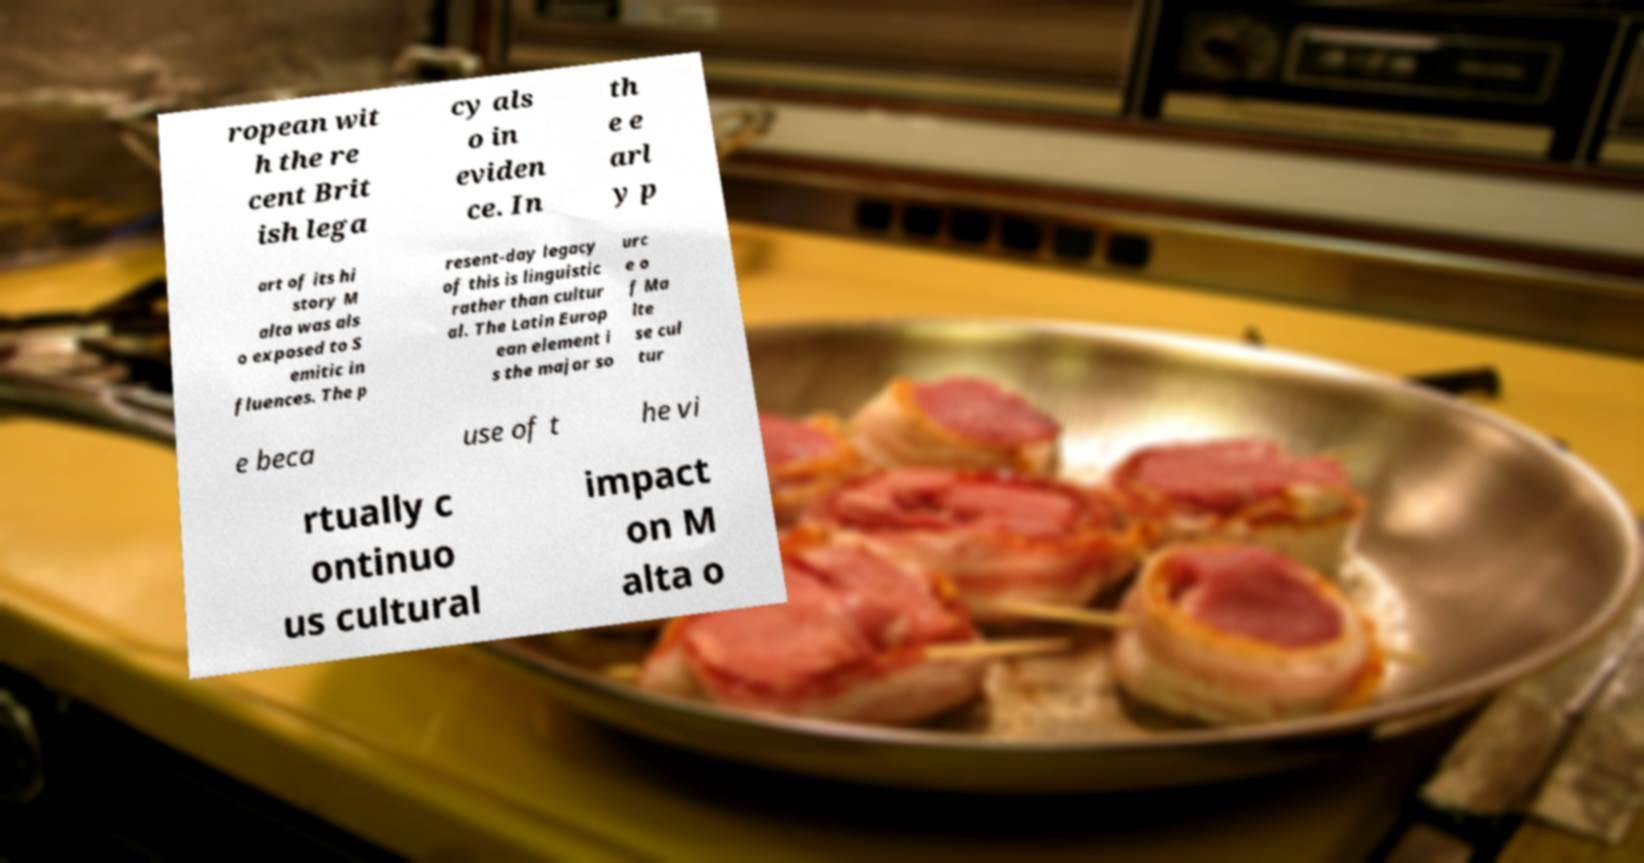Can you read and provide the text displayed in the image?This photo seems to have some interesting text. Can you extract and type it out for me? ropean wit h the re cent Brit ish lega cy als o in eviden ce. In th e e arl y p art of its hi story M alta was als o exposed to S emitic in fluences. The p resent-day legacy of this is linguistic rather than cultur al. The Latin Europ ean element i s the major so urc e o f Ma lte se cul tur e beca use of t he vi rtually c ontinuo us cultural impact on M alta o 